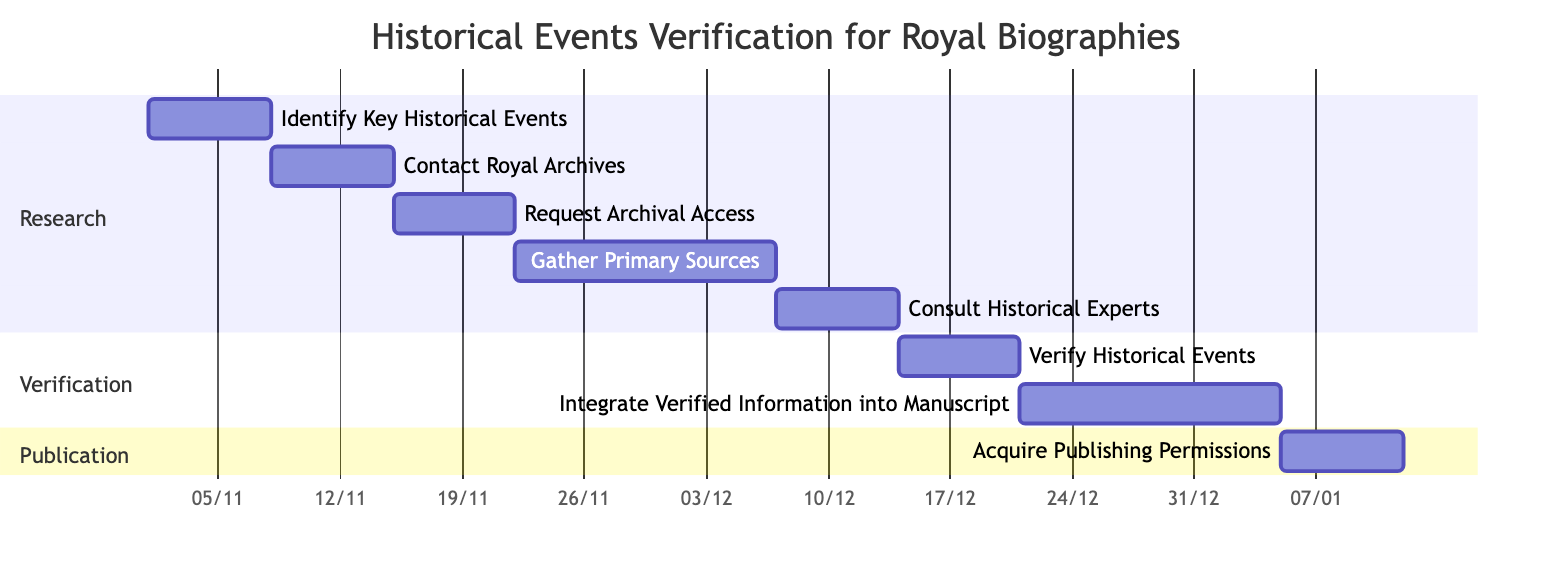What is the duration of the task "Contact Royal Archives"? The task "Contact Royal Archives" starts on November 8, 2023, and ends on November 14, 2023. The duration can be calculated as the difference between the end date and start date, which is 7 days.
Answer: 7 days What task follows "Gather Primary Sources"? "Consult Historical Experts" immediately follows "Gather Primary Sources" in the Gantt Chart, as it is dependent on the completion of the prior task.
Answer: Consult Historical Experts How many tasks are listed in the "Verification" section? There are two tasks in the "Verification" section: "Verify Historical Events" and "Integrate Verified Information into Manuscript". Thus, the total count is 2 tasks.
Answer: 2 tasks What is the earliest starting task in the diagram? The earliest starting task is "Identify Key Historical Events," which begins on November 1, 2023, as it has no dependencies and is the first task listed.
Answer: Identify Key Historical Events Which task is dependent on "Verify Historical Events"? The task that is dependent on "Verify Historical Events" is "Integrate Verified Information into Manuscript," as indicated in the dependencies of the Gantt Chart.
Answer: Integrate Verified Information into Manuscript What is the total duration for the entire verification process, from "Identify Key Historical Events" to "Acquire Publishing Permissions"? The total verification process spans from November 1, 2023, to January 11, 2024. This equates to a total duration of 71 days (from start of the first task to the end of the last task).
Answer: 71 days What is the start date for the "Acquire Publishing Permissions" task? The task "Acquire Publishing Permissions" starts on January 5, 2024, as it is listed directly after the "Integrate Verified Information into Manuscript" task in the Gantt Chart.
Answer: January 5, 2024 